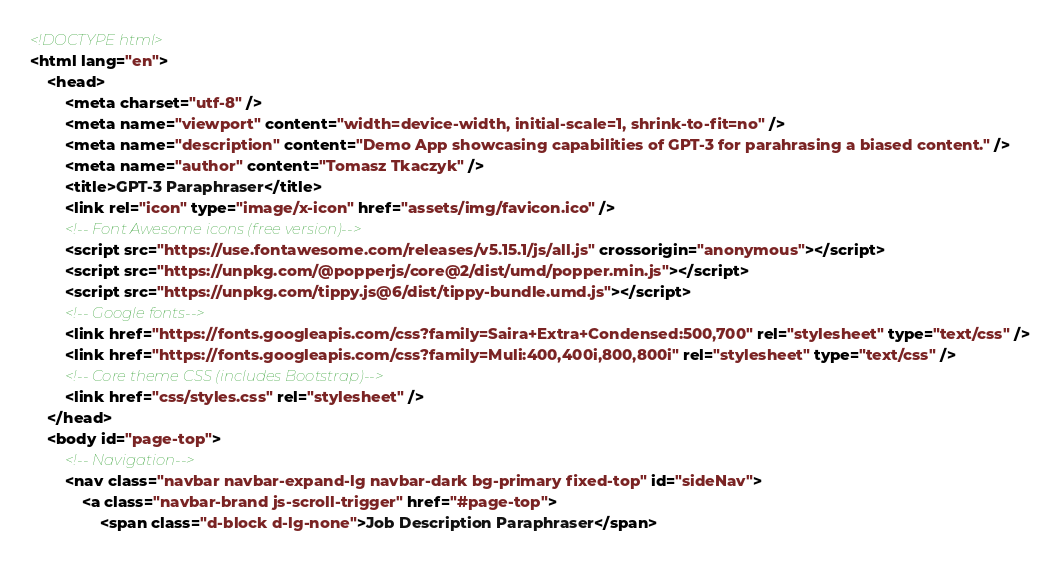Convert code to text. <code><loc_0><loc_0><loc_500><loc_500><_HTML_><!DOCTYPE html>
<html lang="en">
    <head>
        <meta charset="utf-8" />
        <meta name="viewport" content="width=device-width, initial-scale=1, shrink-to-fit=no" />
        <meta name="description" content="Demo App showcasing capabilities of GPT-3 for parahrasing a biased content." />
        <meta name="author" content="Tomasz Tkaczyk" />
        <title>GPT-3 Paraphraser</title>
        <link rel="icon" type="image/x-icon" href="assets/img/favicon.ico" />
        <!-- Font Awesome icons (free version)-->
        <script src="https://use.fontawesome.com/releases/v5.15.1/js/all.js" crossorigin="anonymous"></script>
        <script src="https://unpkg.com/@popperjs/core@2/dist/umd/popper.min.js"></script>
        <script src="https://unpkg.com/tippy.js@6/dist/tippy-bundle.umd.js"></script>
        <!-- Google fonts-->
        <link href="https://fonts.googleapis.com/css?family=Saira+Extra+Condensed:500,700" rel="stylesheet" type="text/css" />
        <link href="https://fonts.googleapis.com/css?family=Muli:400,400i,800,800i" rel="stylesheet" type="text/css" />
        <!-- Core theme CSS (includes Bootstrap)-->
        <link href="css/styles.css" rel="stylesheet" />
    </head>
    <body id="page-top">
        <!-- Navigation-->
        <nav class="navbar navbar-expand-lg navbar-dark bg-primary fixed-top" id="sideNav">
            <a class="navbar-brand js-scroll-trigger" href="#page-top">
                <span class="d-block d-lg-none">Job Description Paraphraser</span></code> 